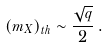<formula> <loc_0><loc_0><loc_500><loc_500>\left ( m _ { X } \right ) _ { t h } \sim \frac { \sqrt { q } } { 2 } \, .</formula> 